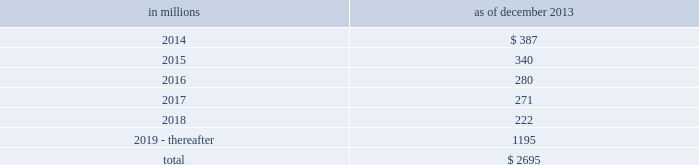Notes to consolidated financial statements sumitomo mitsui financial group , inc .
( smfg ) provides the firm with credit loss protection on certain approved loan commitments ( primarily investment-grade commercial lending commitments ) .
The notional amount of such loan commitments was $ 29.24 billion and $ 32.41 billion as of december 2013 and december 2012 , respectively .
The credit loss protection on loan commitments provided by smfg is generally limited to 95% ( 95 % ) of the first loss the firm realizes on such commitments , up to a maximum of approximately $ 950 million .
In addition , subject to the satisfaction of certain conditions , upon the firm 2019s request , smfg will provide protection for 70% ( 70 % ) of additional losses on such commitments , up to a maximum of $ 1.13 billion , of which $ 870 million and $ 300 million of protection had been provided as of december 2013 and december 2012 , respectively .
The firm also uses other financial instruments to mitigate credit risks related to certain commitments not covered by smfg .
These instruments primarily include credit default swaps that reference the same or similar underlying instrument or entity , or credit default swaps that reference a market index .
Warehouse financing .
The firm provides financing to clients who warehouse financial assets .
These arrangements are secured by the warehoused assets , primarily consisting of corporate loans and commercial mortgage loans .
Contingent and forward starting resale and securities borrowing agreements/forward starting repurchase and secured lending agreements the firm enters into resale and securities borrowing agreements and repurchase and secured lending agreements that settle at a future date , generally within three business days .
The firm also enters into commitments to provide contingent financing to its clients and counterparties through resale agreements .
The firm 2019s funding of these commitments depends on the satisfaction of all contractual conditions to the resale agreement and these commitments can expire unused .
Investment commitments the firm 2019s investment commitments consist of commitments to invest in private equity , real estate and other assets directly and through funds that the firm raises and manages .
These commitments include $ 659 million and $ 872 million as of december 2013 and december 2012 , respectively , related to real estate private investments and $ 6.46 billion and $ 6.47 billion as of december 2013 and december 2012 , respectively , related to corporate and other private investments .
Of these amounts , $ 5.48 billion and $ 6.21 billion as of december 2013 and december 2012 , respectively , relate to commitments to invest in funds managed by the firm .
If these commitments are called , they would be funded at market value on the date of investment .
Leases the firm has contractual obligations under long-term noncancelable lease agreements , principally for office space , expiring on various dates through 2069 .
Certain agreements are subject to periodic escalation provisions for increases in real estate taxes and other charges .
The table below presents future minimum rental payments , net of minimum sublease rentals .
In millions december 2013 .
Rent charged to operating expense was $ 324 million for 2013 , $ 374 million for 2012 and $ 475 million for 2011 .
Operating leases include office space held in excess of current requirements .
Rent expense relating to space held for growth is included in 201coccupancy . 201d the firm records a liability , based on the fair value of the remaining lease rentals reduced by any potential or existing sublease rentals , for leases where the firm has ceased using the space and management has concluded that the firm will not derive any future economic benefits .
Costs to terminate a lease before the end of its term are recognized and measured at fair value on termination .
Contingencies legal proceedings .
See note 27 for information about legal proceedings , including certain mortgage-related matters .
Certain mortgage-related contingencies .
There are multiple areas of focus by regulators , governmental agencies and others within the mortgage market that may impact originators , issuers , servicers and investors .
There remains significant uncertainty surrounding the nature and extent of any potential exposure for participants in this market .
182 goldman sachs 2013 annual report .
What percentage of future minimum rental payments are due in 2014? 
Computations: (387 / 2695)
Answer: 0.1436. 